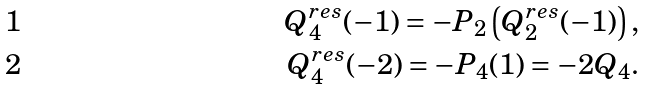<formula> <loc_0><loc_0><loc_500><loc_500>Q _ { 4 } ^ { r e s } ( - 1 ) = - P _ { 2 } \left ( Q _ { 2 } ^ { r e s } ( - 1 ) \right ) , \\ Q _ { 4 } ^ { r e s } ( - 2 ) = - P _ { 4 } ( 1 ) = - 2 Q _ { 4 } .</formula> 